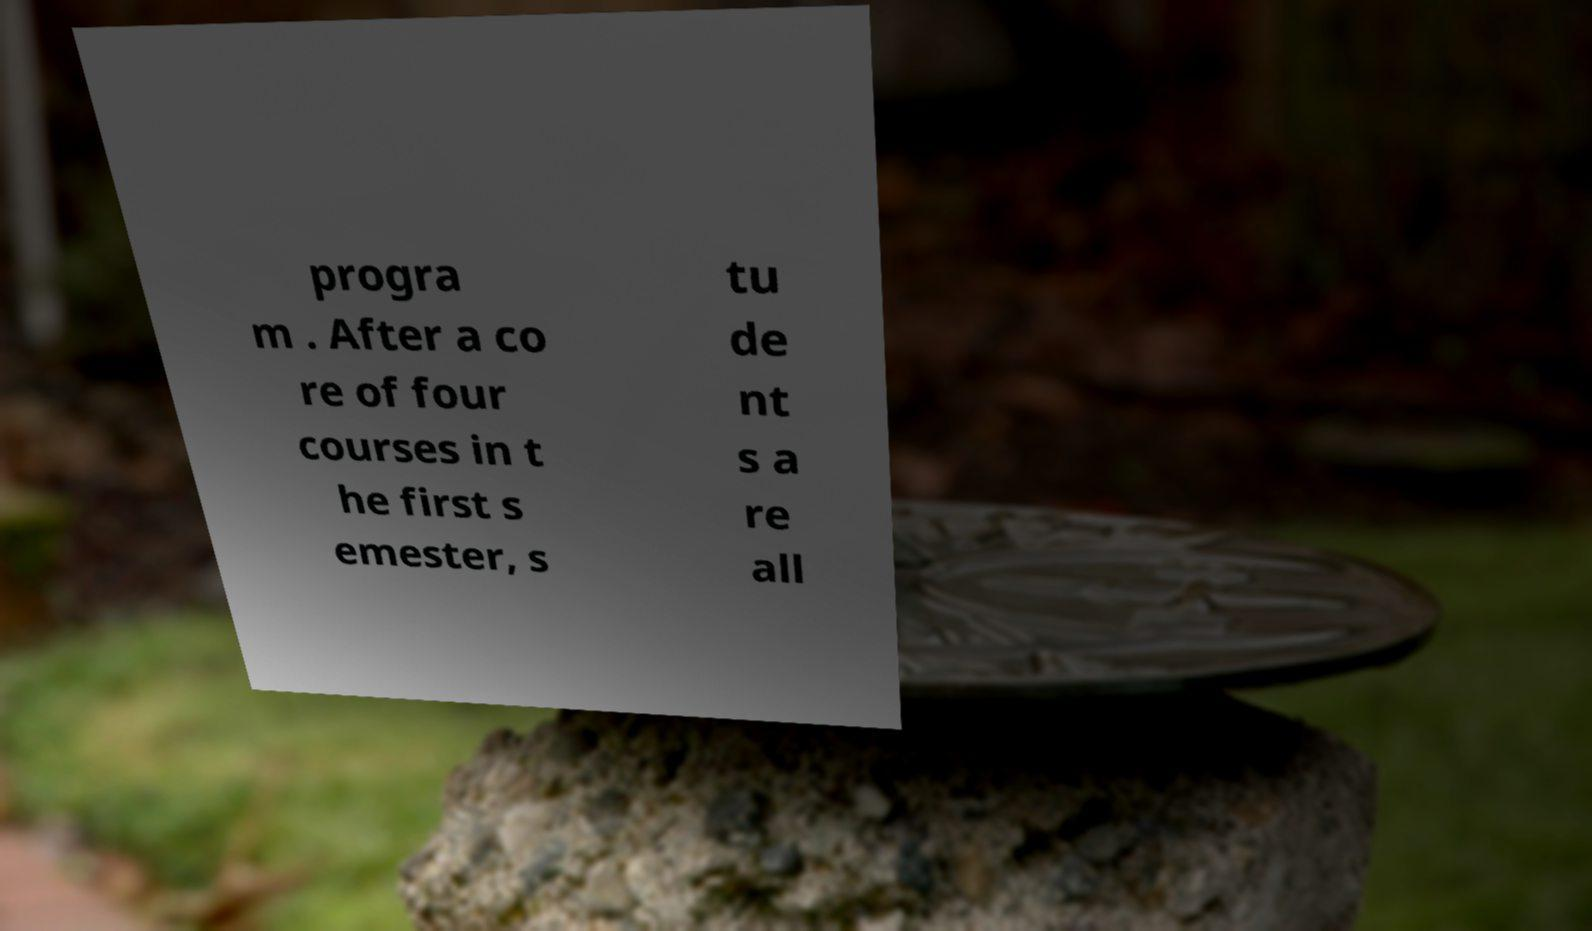Please identify and transcribe the text found in this image. progra m . After a co re of four courses in t he first s emester, s tu de nt s a re all 